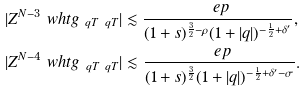<formula> <loc_0><loc_0><loc_500><loc_500>& | Z ^ { N - 3 } \ w h t g _ { \ q T \ q T } | \lesssim \frac { \ e p } { ( 1 + s ) ^ { \frac { 3 } { 2 } - \rho } ( 1 + | q | ) ^ { - \frac { 1 } { 2 } + \delta ^ { \prime } } } , \\ & | Z ^ { N - 4 } \ w h t g _ { \ q T \ q T } | \lesssim \frac { \ e p } { ( 1 + s ) ^ { \frac { 3 } { 2 } } ( 1 + | q | ) ^ { - \frac { 1 } { 2 } + \delta ^ { \prime } - \sigma } } .</formula> 